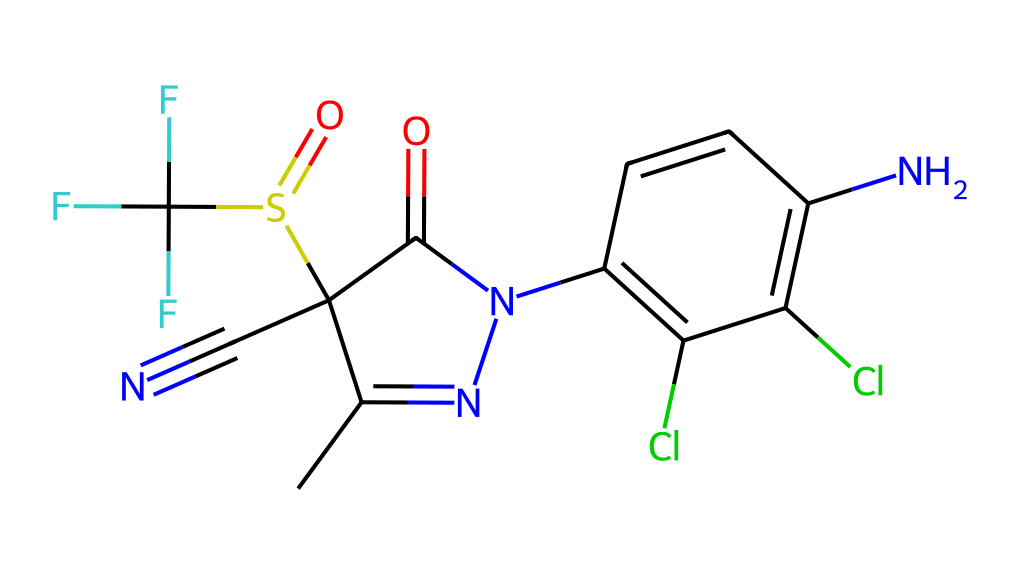What is the molecular formula of fipronil? To find the molecular formula, count the number of each type of atom present in the SMILES representation. The relevant atoms are: Carbon (C), Hydrogen (H), Nitrogen (N), Oxygen (O), Sulfur (S), Chlorine (Cl), and Fluorine (F). Upon analysis, the count reveals the molecular formula C12H4Cl2F3N4O2S.
Answer: C12H4Cl2F3N4O2S How many nitrogen atoms are in fipronil? By examining the SMILES representation, we can identify the nitrogen atoms denoted as 'N'. In total, there are four nitrogen atoms present.
Answer: 4 What type of pesticide is fipronil classified as? Fipronil is classified as a broad-spectrum insecticide. This classification is based on its ability to target a wide range of insects rather than being specific to one type of pest.
Answer: broad-spectrum insecticide What functional groups are present in fipronil? Analyzing the structure, we can identify primary functional groups such as sulfonamide (due to the sulfur and oxygen), carbonyl (from the carbonyl C=O), and nitrile (from the C#N). Thus, the key functional groups are sulfonamide and nitrile.
Answer: sulfonamide, nitrile What is the total number of rings present in the fipronil structure? Inspecting the chemical's visual representation shows that there are two distinct ring structures involved in the overall architecture of fipronil.
Answer: 2 How many fluorine atoms are present in the fipronil structure? By counting the instances of the 'F' notation in the SMILES representation, we find that there are three fluorine atoms in total.
Answer: 3 